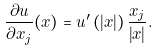<formula> <loc_0><loc_0><loc_500><loc_500>\frac { \partial u } { \partial x _ { j } } ( x ) = u ^ { \prime } \left ( \left | x \right | \right ) \frac { x _ { j } } { \left | x \right | } .</formula> 